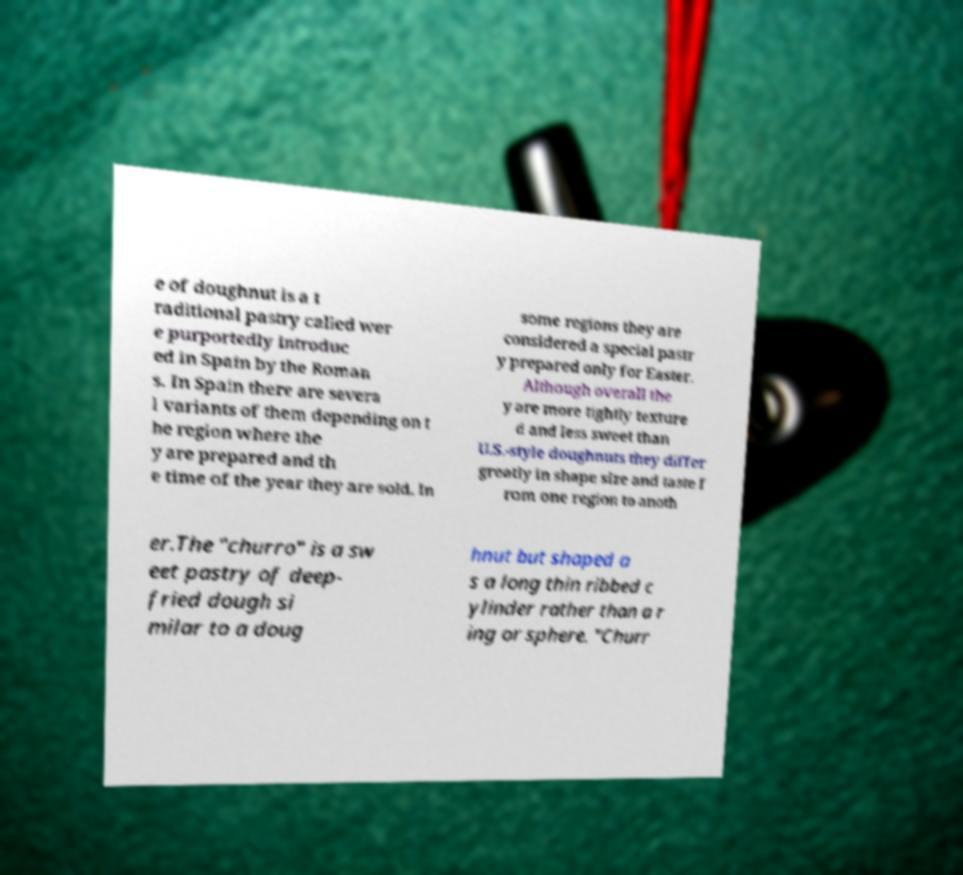I need the written content from this picture converted into text. Can you do that? e of doughnut is a t raditional pastry called wer e purportedly introduc ed in Spain by the Roman s. In Spain there are severa l variants of them depending on t he region where the y are prepared and th e time of the year they are sold. In some regions they are considered a special pastr y prepared only for Easter. Although overall the y are more tightly texture d and less sweet than U.S.-style doughnuts they differ greatly in shape size and taste f rom one region to anoth er.The "churro" is a sw eet pastry of deep- fried dough si milar to a doug hnut but shaped a s a long thin ribbed c ylinder rather than a r ing or sphere. "Churr 